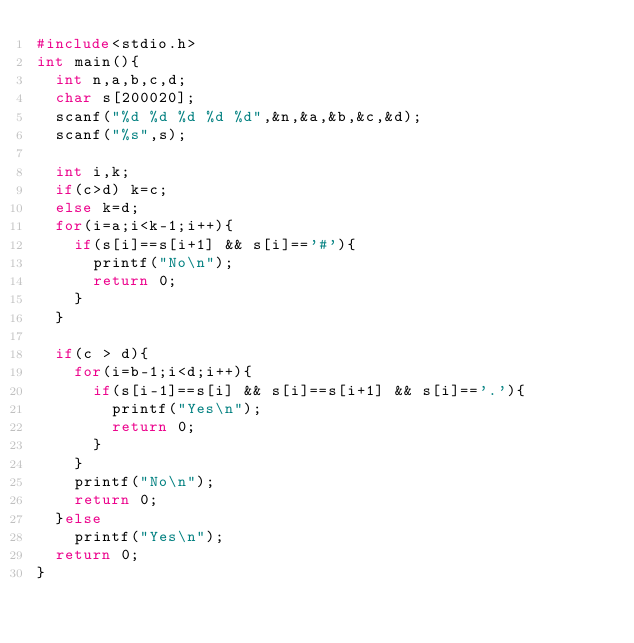<code> <loc_0><loc_0><loc_500><loc_500><_C_>#include<stdio.h>
int main(){
  int n,a,b,c,d;
  char s[200020];
  scanf("%d %d %d %d %d",&n,&a,&b,&c,&d);
  scanf("%s",s);

  int i,k;
  if(c>d) k=c;
  else k=d;
  for(i=a;i<k-1;i++){
    if(s[i]==s[i+1] && s[i]=='#'){
      printf("No\n");
      return 0;
    }
  }

  if(c > d){
    for(i=b-1;i<d;i++){
      if(s[i-1]==s[i] && s[i]==s[i+1] && s[i]=='.'){
        printf("Yes\n");
        return 0;
      }
    }
    printf("No\n");
    return 0;
  }else
    printf("Yes\n");
  return 0;
}
</code> 